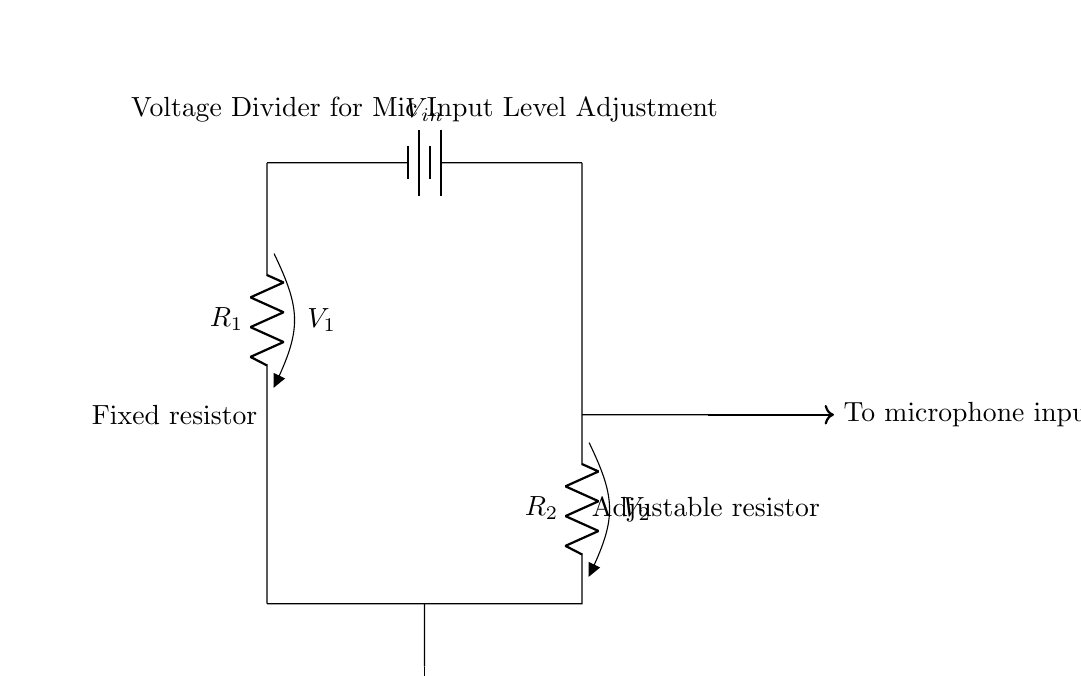What is the component that adjusts the microphone input? The component used to adjust the microphone input is the adjustable resistor, also known as a potentiometer. It allows you to change the resistance value and thereby modify the voltage going into the microphone.
Answer: Adjustable resistor What are the resistors labeled in the circuit? The resistors in the circuit are labeled R1 and R2. The fixed resistor is R1, and the adjustable one is R2. This helps to identify their functions within the voltage divider.
Answer: R1 and R2 What kind of circuit is this? This circuit is a voltage divider circuit, which is specifically designed to reduce the voltage level for input into the microphone. It utilizes the properties of series resistors to create a specific output voltage.
Answer: Voltage divider circuit What is the purpose of the circuit? The purpose of the circuit is to adjust microphone input levels. The voltage divider allows for control over the voltage supplied to the microphone, ensuring optimal performance and preventing distortion.
Answer: Adjust microphone input levels What happens to the voltage when the adjustable resistor is increased? When the adjustable resistor (R2) is increased, the output voltage to the microphone decreases. This is because a larger resistance in the voltage divider formula leads to a larger share of the total voltage drop across R1, lowering the voltage available to the load (microphone).
Answer: Decreases What is the input voltage for this circuit? The input voltage for this circuit is denoted as V_in, which is connected to the top of the voltage divider. This is the voltage supplied from the battery to power the circuit.
Answer: V_in 